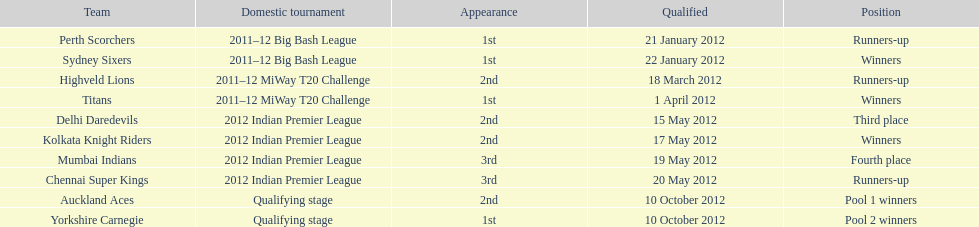Which teams were the last to qualify? Auckland Aces, Yorkshire Carnegie. 